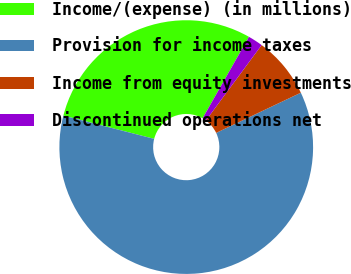<chart> <loc_0><loc_0><loc_500><loc_500><pie_chart><fcel>Income/(expense) (in millions)<fcel>Provision for income taxes<fcel>Income from equity investments<fcel>Discontinued operations net<nl><fcel>29.23%<fcel>61.05%<fcel>7.82%<fcel>1.9%<nl></chart> 